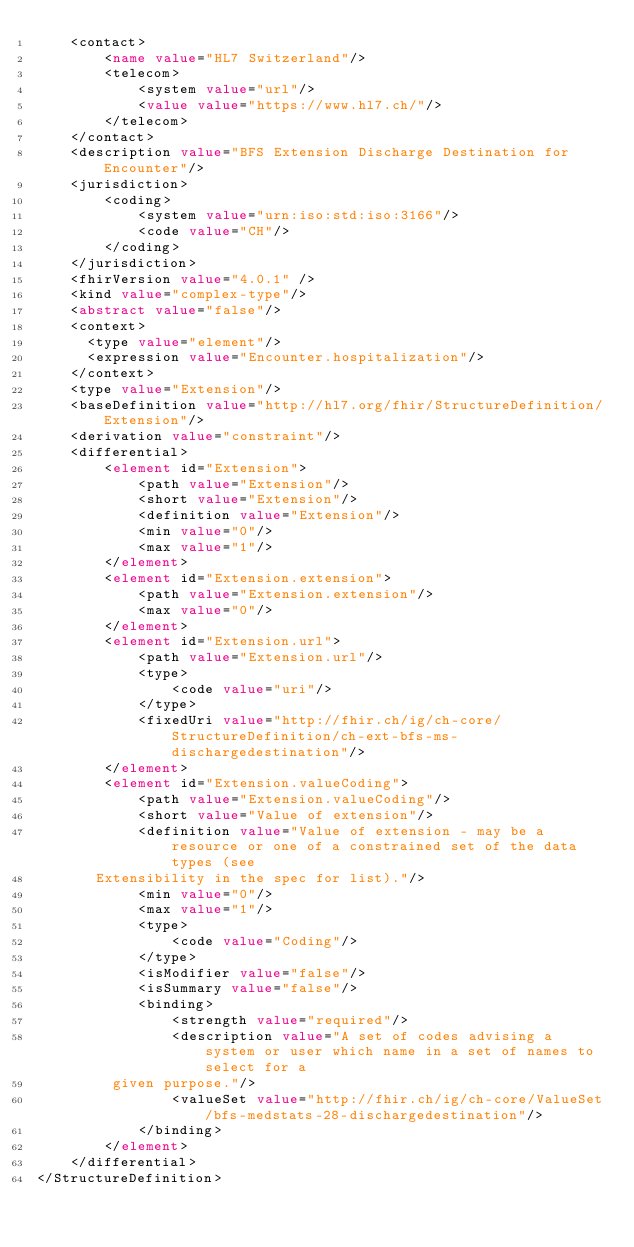<code> <loc_0><loc_0><loc_500><loc_500><_XML_>    <contact>
        <name value="HL7 Switzerland"/>
        <telecom>
            <system value="url"/>
            <value value="https://www.hl7.ch/"/>
        </telecom>
    </contact>
    <description value="BFS Extension Discharge Destination for Encounter"/>
    <jurisdiction>
        <coding>
            <system value="urn:iso:std:iso:3166"/>
            <code value="CH"/>
        </coding>
    </jurisdiction>
    <fhirVersion value="4.0.1" />
    <kind value="complex-type"/>
    <abstract value="false"/>
    <context>
      <type value="element"/>
      <expression value="Encounter.hospitalization"/>
    </context>
    <type value="Extension"/>
    <baseDefinition value="http://hl7.org/fhir/StructureDefinition/Extension"/>
    <derivation value="constraint"/>
    <differential>
        <element id="Extension">
            <path value="Extension"/>
            <short value="Extension"/>
            <definition value="Extension"/>
            <min value="0"/>
            <max value="1"/>
        </element>
        <element id="Extension.extension">
            <path value="Extension.extension"/>
            <max value="0"/>
        </element>
        <element id="Extension.url">
            <path value="Extension.url"/>
            <type>
                <code value="uri"/>
            </type>
            <fixedUri value="http://fhir.ch/ig/ch-core/StructureDefinition/ch-ext-bfs-ms-dischargedestination"/>
        </element>
        <element id="Extension.valueCoding">
            <path value="Extension.valueCoding"/>
            <short value="Value of extension"/>
            <definition value="Value of extension - may be a resource or one of a constrained set of the data types (see
       Extensibility in the spec for list)."/>
            <min value="0"/>
            <max value="1"/>
            <type>
                <code value="Coding"/>
            </type>
            <isModifier value="false"/>
            <isSummary value="false"/>
            <binding>
                <strength value="required"/>
                <description value="A set of codes advising a system or user which name in a set of names to select for a
         given purpose."/>
                <valueSet value="http://fhir.ch/ig/ch-core/ValueSet/bfs-medstats-28-dischargedestination"/>
            </binding>
        </element>
    </differential>
</StructureDefinition> </code> 